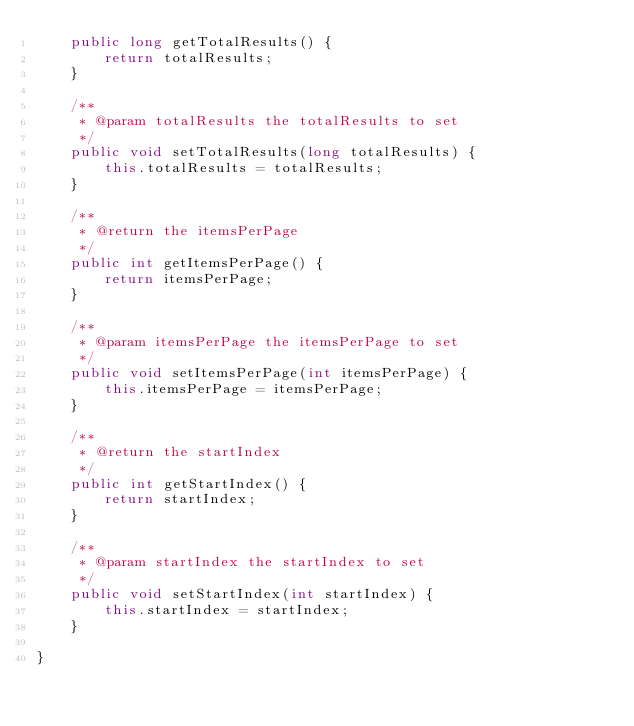Convert code to text. <code><loc_0><loc_0><loc_500><loc_500><_Java_>    public long getTotalResults() {
        return totalResults;
    }

    /**
     * @param totalResults the totalResults to set
     */
    public void setTotalResults(long totalResults) {
        this.totalResults = totalResults;
    }

    /**
     * @return the itemsPerPage
     */
    public int getItemsPerPage() {
        return itemsPerPage;
    }

    /**
     * @param itemsPerPage the itemsPerPage to set
     */
    public void setItemsPerPage(int itemsPerPage) {
        this.itemsPerPage = itemsPerPage;
    }

    /**
     * @return the startIndex
     */
    public int getStartIndex() {
        return startIndex;
    }

    /**
     * @param startIndex the startIndex to set
     */
    public void setStartIndex(int startIndex) {
        this.startIndex = startIndex;
    }

}
</code> 